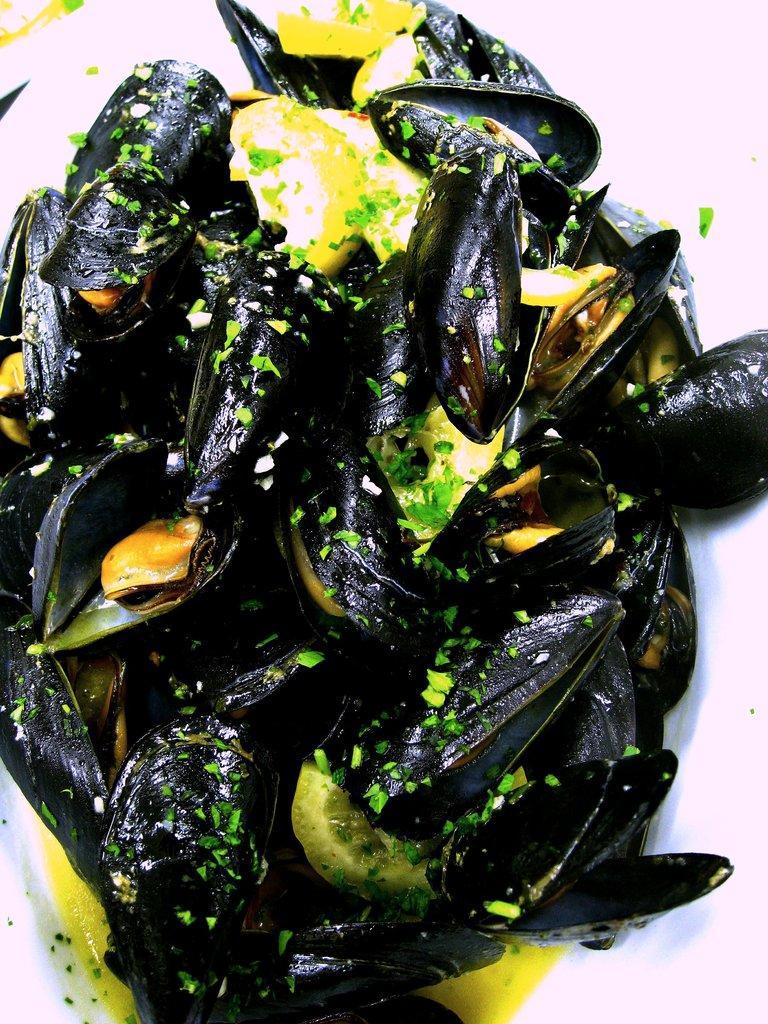Describe this image in one or two sentences. In this image, we can see a food item which is called as Mussel. 